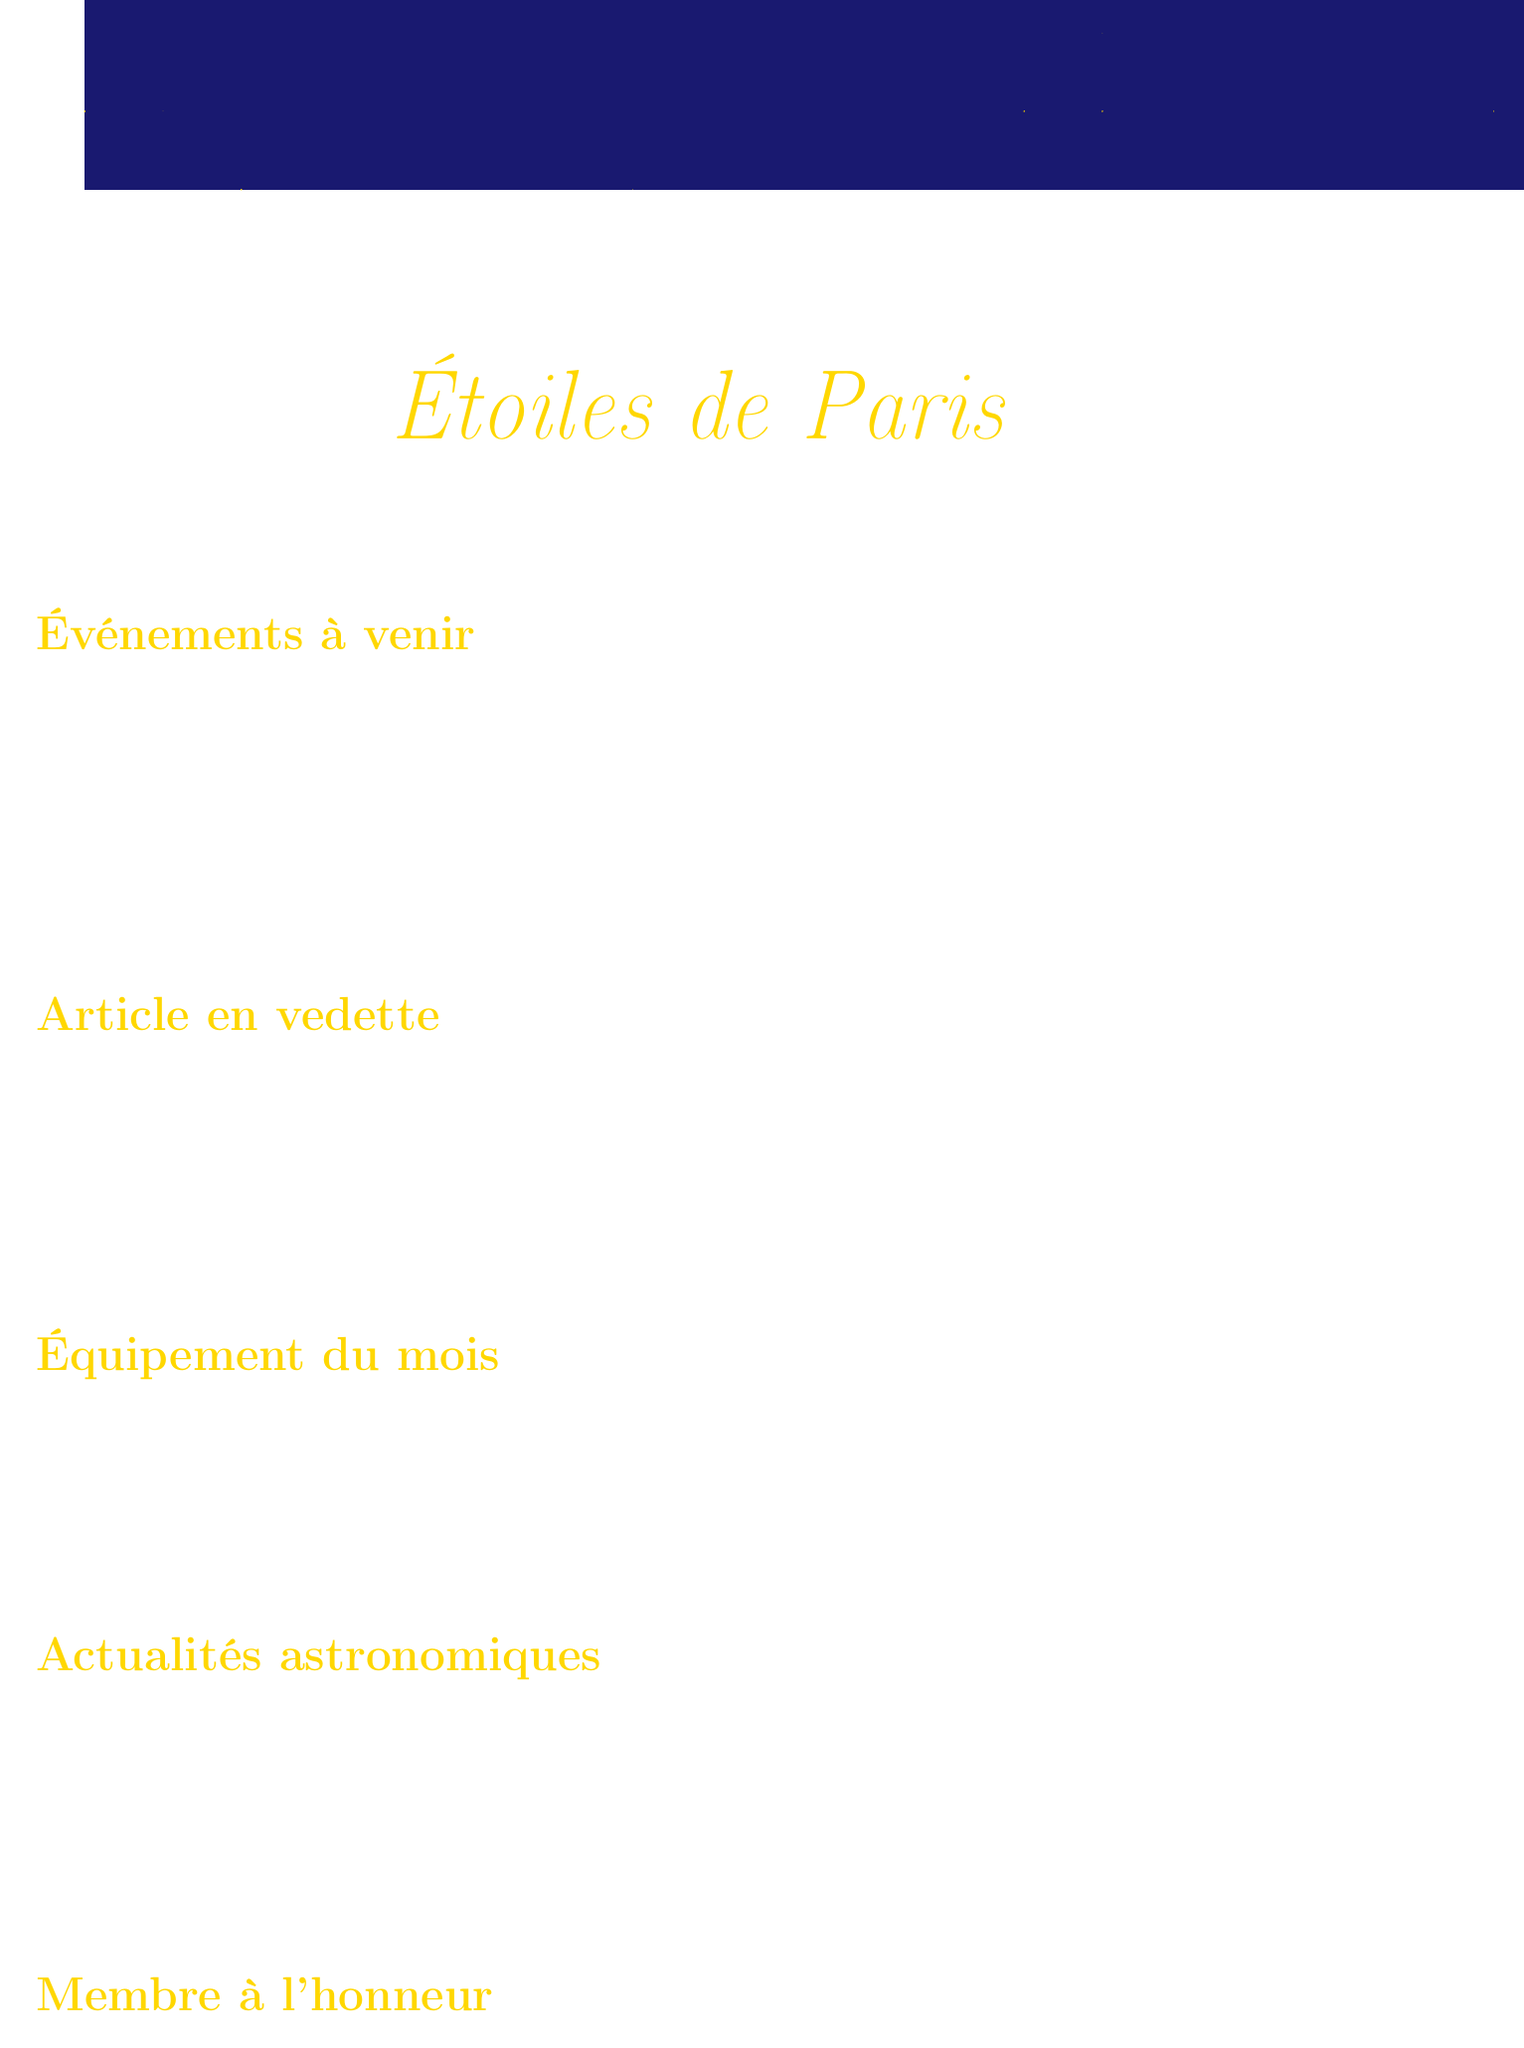Quels sont les événements à venir ? The upcoming events listed in the document include a stargazing event and a conference.
Answer: Nuit des Étoiles au Parc de Sceaux, Les exoplanètes : à la recherche d'une nouvelle Terre Qui est le conférencier de la conférence sur les exoplanètes ? The document specifies that the speaker for the conference is Dr. Anne Dupont.
Answer: Dr. Anne Dupont Quand aura lieu la Nuit des Étoiles ? The specific date for the Nuit des Étoiles event is detailed in the document.
Answer: 15 août 2023 Quel équipement est mis en avant ce mois-ci ? The document highlights the equipment available for the upcoming observation night.
Answer: Télescope Dobson SkyWatcher 254/1200 GoTo Quel est le titre de l'article en vedette ? The featured article title is mentioned in the document.
Answer: La mission JUICE de l'ESA : explorer les lunes glacées de Jupiter Quel est le sujet de la dernière actualité astronomique ? The subject of the astronomy news article discusses a discovery in the document.
Answer: Découverte d'une nouvelle comète interstellaire Qui a remporté le prix de la meilleure photo astronomique amateur ? The document recognizes a member for her achievement in photography.
Answer: Sophie Legrand Quelle astuce est donnée pour profiter des observations nocturnes ? The document provides a specific tip for stargazing observations.
Answer: Utiliser une lampe rouge Combien de temps avant de commencer les observations doit-on s’habituer à l’obscurité ? The document states a specific duration for preparation before stargazing.
Answer: 30 minutes 